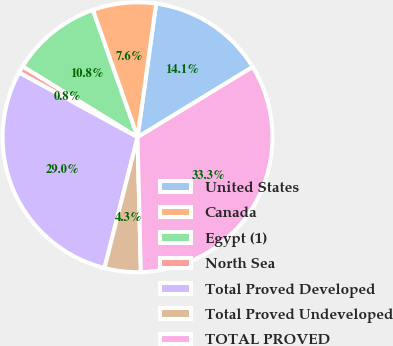<chart> <loc_0><loc_0><loc_500><loc_500><pie_chart><fcel>United States<fcel>Canada<fcel>Egypt (1)<fcel>North Sea<fcel>Total Proved Developed<fcel>Total Proved Undeveloped<fcel>TOTAL PROVED<nl><fcel>14.08%<fcel>7.58%<fcel>10.83%<fcel>0.84%<fcel>29.02%<fcel>4.33%<fcel>33.34%<nl></chart> 